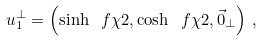<formula> <loc_0><loc_0><loc_500><loc_500>u _ { 1 } ^ { \perp } = \left ( \sinh \ f { \chi } { 2 } , \cosh \ f { \chi } { 2 } , \vec { 0 } _ { \perp } \right ) \, ,</formula> 